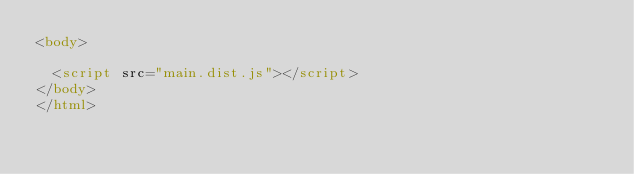<code> <loc_0><loc_0><loc_500><loc_500><_HTML_><body>
	
	<script src="main.dist.js"></script>
</body>
</html></code> 